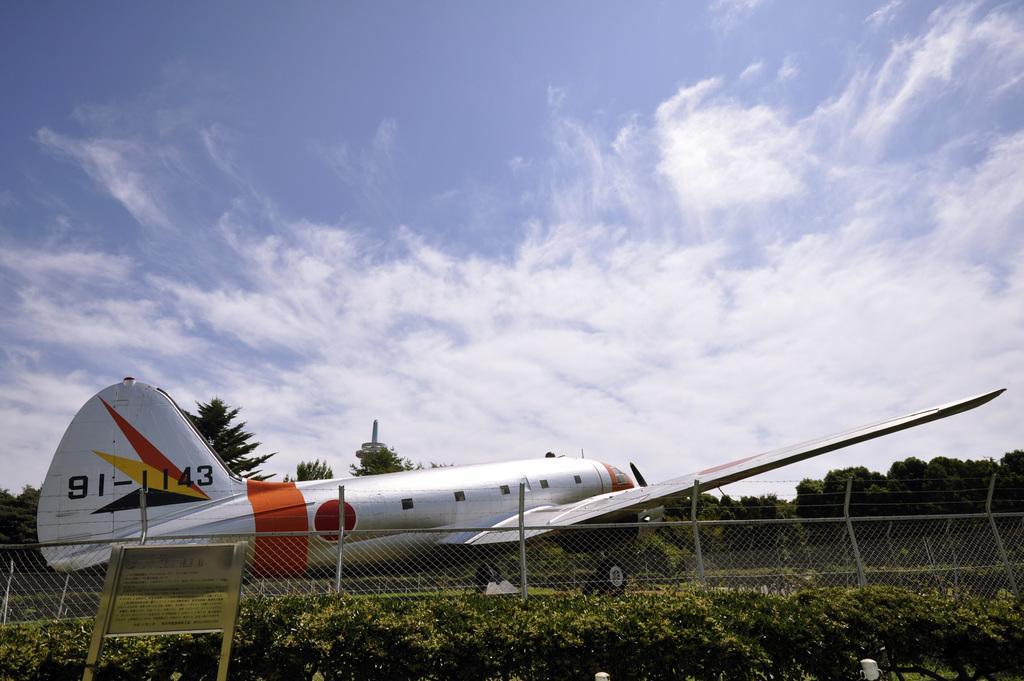Can you describe this image briefly? There is an aeroplane. Here we can see a fence, plants, board, and trees. In the background there is sky with clouds. 